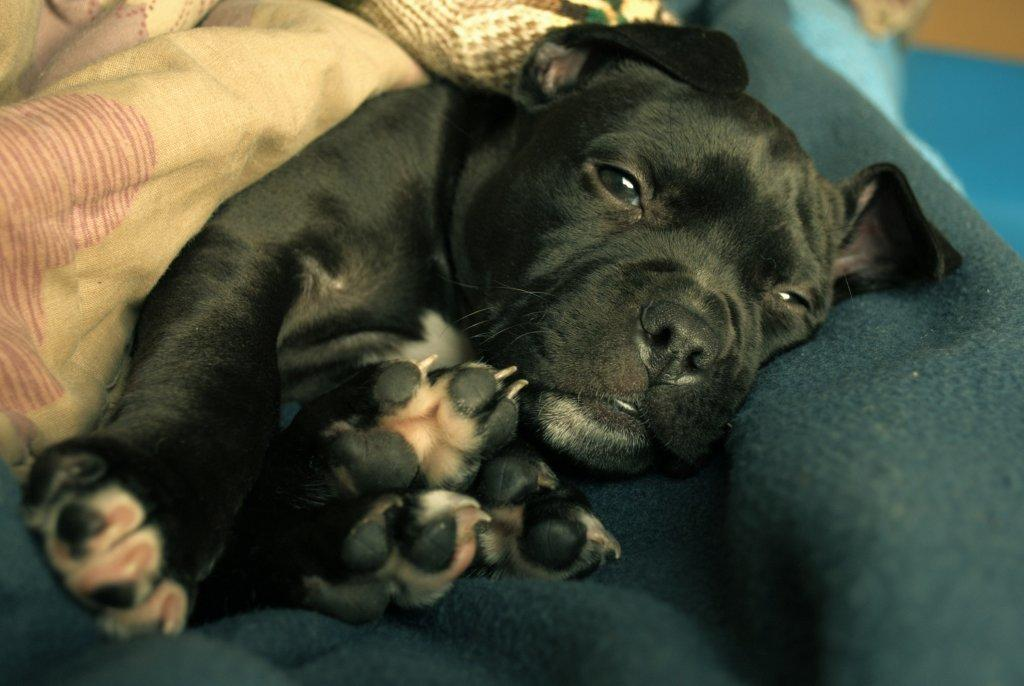What type of animal is present in the image? There is a dog in the image. What is the dog doing in the image? The dog is laying on a cloth. What type of squirrel can be seen climbing the frame in the image? There is no squirrel or frame present in the image; it features a dog laying on a cloth. 